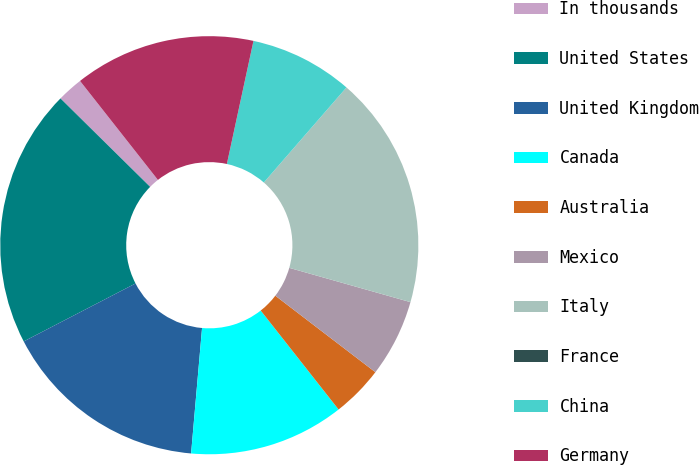Convert chart to OTSL. <chart><loc_0><loc_0><loc_500><loc_500><pie_chart><fcel>In thousands<fcel>United States<fcel>United Kingdom<fcel>Canada<fcel>Australia<fcel>Mexico<fcel>Italy<fcel>France<fcel>China<fcel>Germany<nl><fcel>2.0%<fcel>20.0%<fcel>16.0%<fcel>12.0%<fcel>4.0%<fcel>6.0%<fcel>18.0%<fcel>0.0%<fcel>8.0%<fcel>14.0%<nl></chart> 